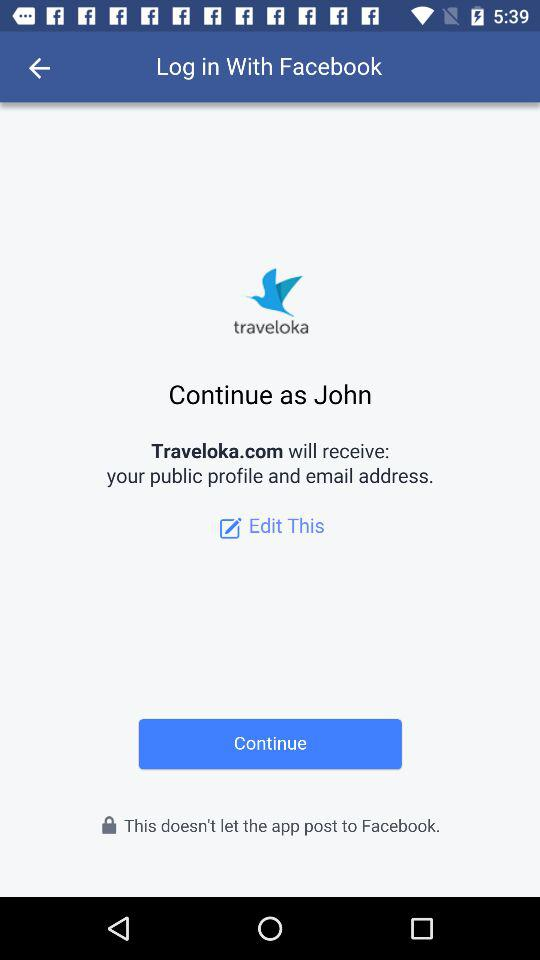Through what application can be login with? You can login with Facebook. 